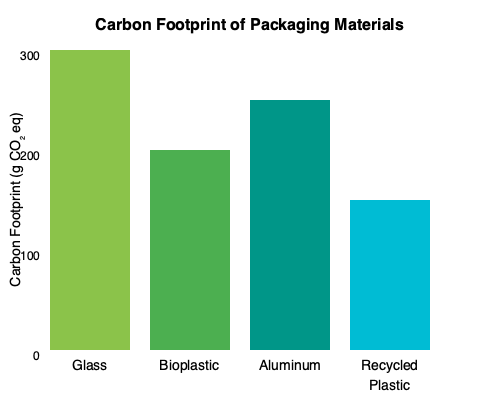As an organic skincare brand owner committed to minimizing environmental impact, which packaging material would you choose based on the carbon footprint data presented in the bar graph, and why? To answer this question, we need to analyze the carbon footprint data for each packaging material shown in the bar graph:

1. Glass: Approximately 300 g CO₂ eq
2. Bioplastic: Approximately 200 g CO₂ eq
3. Aluminum: Approximately 250 g CO₂ eq
4. Recycled Plastic: Approximately 150 g CO₂ eq

Step 1: Identify the material with the lowest carbon footprint.
The bar graph clearly shows that recycled plastic has the shortest bar, indicating the lowest carbon footprint among the options presented.

Step 2: Consider the environmental impact.
As an organic skincare brand owner committed to minimizing environmental impact, the primary goal would be to choose the packaging material with the lowest carbon footprint.

Step 3: Evaluate additional factors.
While recycled plastic has the lowest carbon footprint, it's important to note that it's still a plastic product. However, using recycled plastic supports the circular economy and reduces the demand for virgin plastic production.

Step 4: Make the decision.
Based on the carbon footprint data alone, recycled plastic would be the best choice for minimizing environmental impact. It has the lowest carbon footprint (approximately 150 g CO₂ eq) among the options presented, which aligns with the goal of reducing the brand's environmental impact.
Answer: Recycled plastic, as it has the lowest carbon footprint (150 g CO₂ eq) among the options presented. 